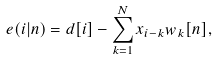<formula> <loc_0><loc_0><loc_500><loc_500>e ( i | n ) = d [ i ] - \sum _ { k = 1 } ^ { N } x _ { i - k } w _ { k } [ n ] ,</formula> 